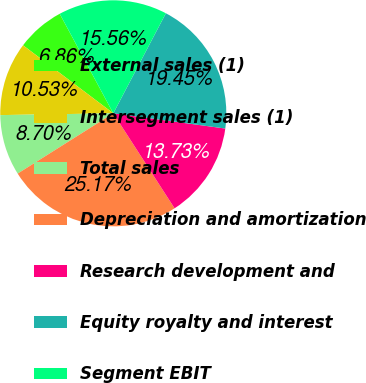<chart> <loc_0><loc_0><loc_500><loc_500><pie_chart><fcel>External sales (1)<fcel>Intersegment sales (1)<fcel>Total sales<fcel>Depreciation and amortization<fcel>Research development and<fcel>Equity royalty and interest<fcel>Segment EBIT<nl><fcel>6.86%<fcel>10.53%<fcel>8.7%<fcel>25.17%<fcel>13.73%<fcel>19.45%<fcel>15.56%<nl></chart> 